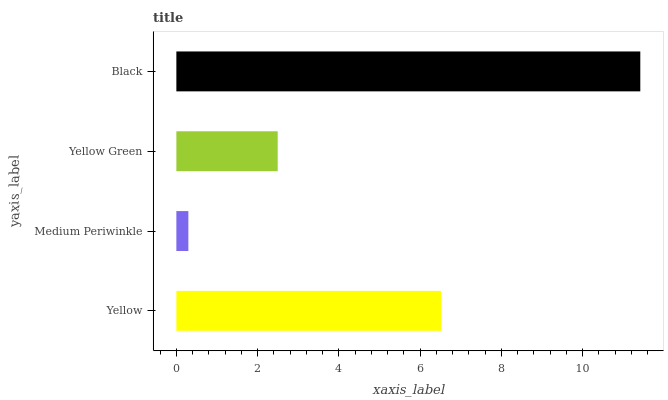Is Medium Periwinkle the minimum?
Answer yes or no. Yes. Is Black the maximum?
Answer yes or no. Yes. Is Yellow Green the minimum?
Answer yes or no. No. Is Yellow Green the maximum?
Answer yes or no. No. Is Yellow Green greater than Medium Periwinkle?
Answer yes or no. Yes. Is Medium Periwinkle less than Yellow Green?
Answer yes or no. Yes. Is Medium Periwinkle greater than Yellow Green?
Answer yes or no. No. Is Yellow Green less than Medium Periwinkle?
Answer yes or no. No. Is Yellow the high median?
Answer yes or no. Yes. Is Yellow Green the low median?
Answer yes or no. Yes. Is Medium Periwinkle the high median?
Answer yes or no. No. Is Black the low median?
Answer yes or no. No. 